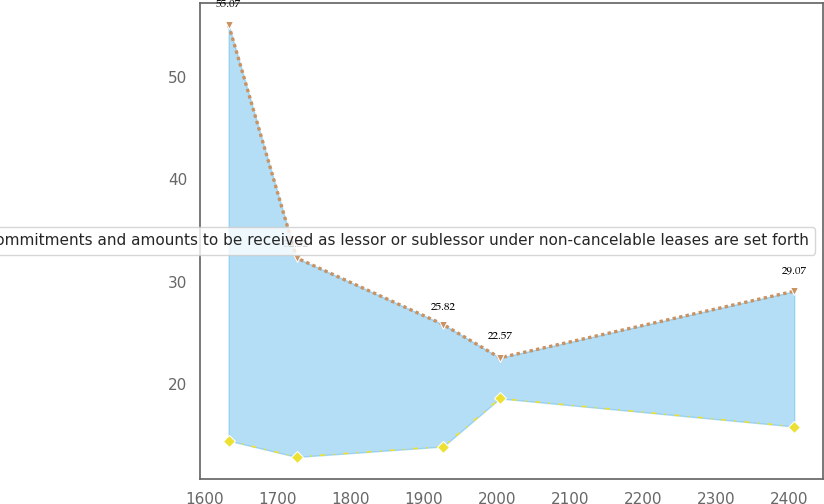<chart> <loc_0><loc_0><loc_500><loc_500><line_chart><ecel><fcel>Unnamed: 1<fcel>Future minimum commitments and amounts to be received as lessor or sublessor under non-cancelable leases are set forth<nl><fcel>1632.53<fcel>55.07<fcel>14.48<nl><fcel>1725.57<fcel>32.32<fcel>12.89<nl><fcel>1926.33<fcel>25.82<fcel>13.91<nl><fcel>2003.75<fcel>22.57<fcel>18.6<nl><fcel>2406.75<fcel>29.07<fcel>15.86<nl></chart> 